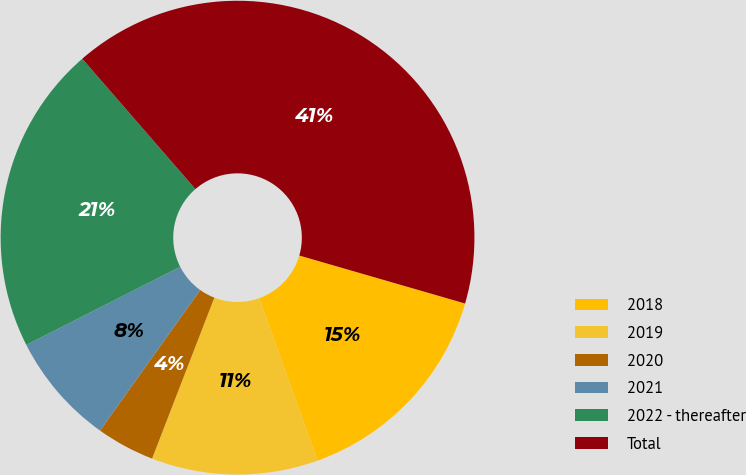Convert chart to OTSL. <chart><loc_0><loc_0><loc_500><loc_500><pie_chart><fcel>2018<fcel>2019<fcel>2020<fcel>2021<fcel>2022 - thereafter<fcel>Total<nl><fcel>15.04%<fcel>11.35%<fcel>3.98%<fcel>7.67%<fcel>21.1%<fcel>40.86%<nl></chart> 